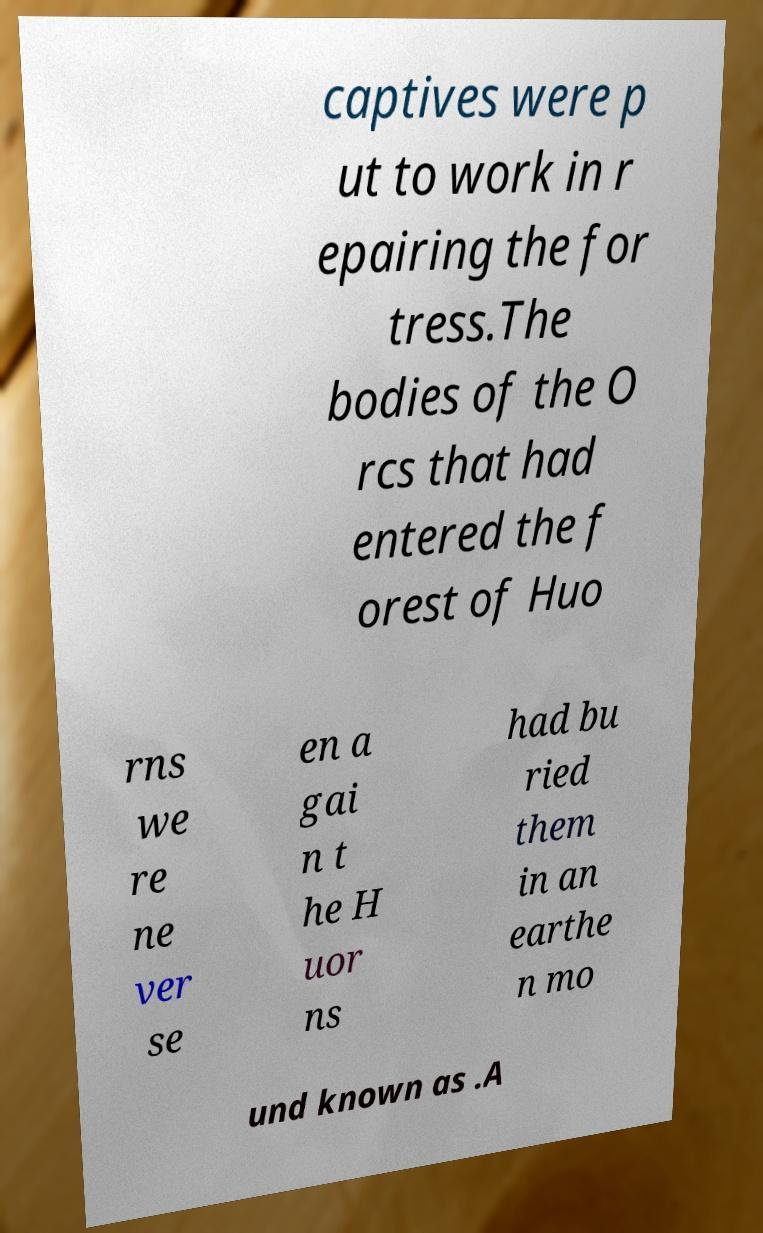What messages or text are displayed in this image? I need them in a readable, typed format. captives were p ut to work in r epairing the for tress.The bodies of the O rcs that had entered the f orest of Huo rns we re ne ver se en a gai n t he H uor ns had bu ried them in an earthe n mo und known as .A 